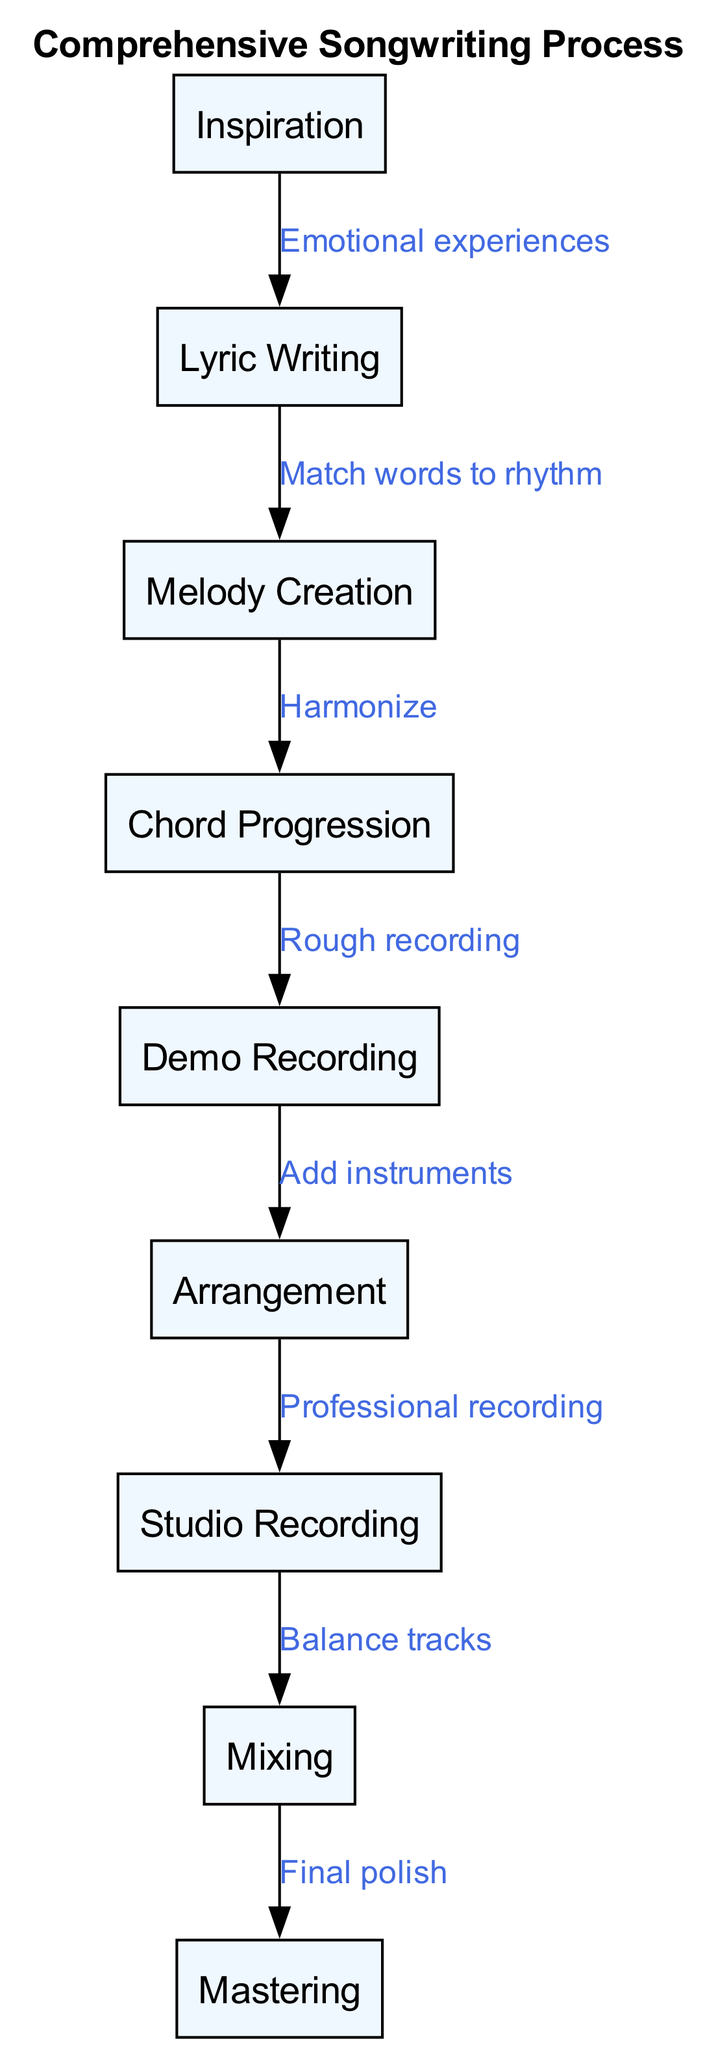What is the first stage in the songwriting process? The diagram starts with the node labeled "Inspiration," indicating that it is the first stage in the songwriting process.
Answer: Inspiration How many stages are there in total? Counting all nodes listed in the diagram, there are nine distinct stages in the songwriting process.
Answer: 9 What follows after "Lyric Writing"? The arrow from "Lyric Writing" points to "Melody Creation," indicating that this is the next stage after writing lyrics.
Answer: Melody Creation What is the relationship between "Mixing" and "Mastering"? The edge connecting "Mixing" to "Mastering" shows a sequential relationship, where mixing involves balancing tracks prior to the final polishing stage known as mastering.
Answer: Final polish Which stage comes before "Studio Recording"? The diagram shows an arrow pointing from "Arrangement" to "Studio Recording," indicating that arrangement precedes studio recording.
Answer: Arrangement What emotion influences the first stage "Inspiration"? The edge labeled "Emotional experiences" connects "Inspiration" to "Lyric Writing," indicating that emotional experiences influence the initial stage of inspiration.
Answer: Emotional experiences How many edges are in the diagram? By counting all the directed connections listed between nodes, there are eight edges in total that define the flow of the songwriting process.
Answer: 8 What is the main activity in the "Demo Recording" stage? The edge labeled "Rough recording" that points from "Chord Progression" to "Demo Recording" indicates that the primary activity during this stage is creating a rough recording.
Answer: Rough recording Which two stages involve the addition of instruments? The stage labeled "Arrangement" follows "Demo Recording," where instruments are added and then continues to "Studio Recording," reinforcing the role of instruments in both stages.
Answer: Add instruments 